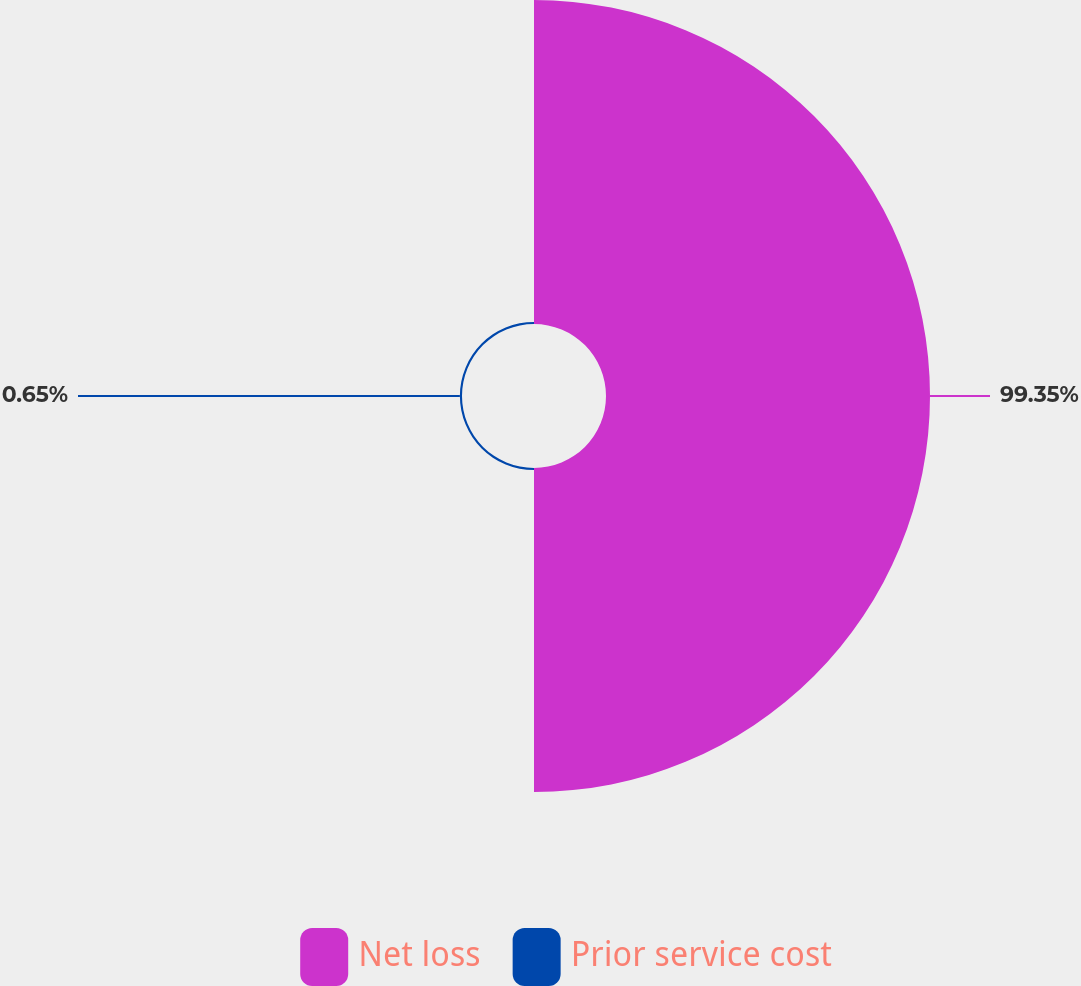Convert chart. <chart><loc_0><loc_0><loc_500><loc_500><pie_chart><fcel>Net loss<fcel>Prior service cost<nl><fcel>99.35%<fcel>0.65%<nl></chart> 